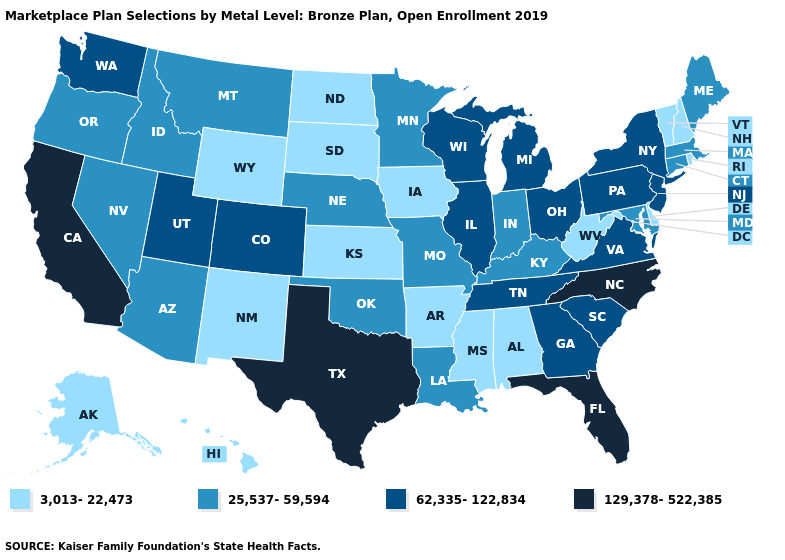What is the value of Maryland?
Write a very short answer. 25,537-59,594. What is the value of Virginia?
Concise answer only. 62,335-122,834. Name the states that have a value in the range 3,013-22,473?
Write a very short answer. Alabama, Alaska, Arkansas, Delaware, Hawaii, Iowa, Kansas, Mississippi, New Hampshire, New Mexico, North Dakota, Rhode Island, South Dakota, Vermont, West Virginia, Wyoming. Does North Carolina have a higher value than Florida?
Give a very brief answer. No. What is the lowest value in the USA?
Keep it brief. 3,013-22,473. Which states have the highest value in the USA?
Give a very brief answer. California, Florida, North Carolina, Texas. Does California have the highest value in the USA?
Answer briefly. Yes. Does Nevada have the same value as West Virginia?
Concise answer only. No. Name the states that have a value in the range 62,335-122,834?
Quick response, please. Colorado, Georgia, Illinois, Michigan, New Jersey, New York, Ohio, Pennsylvania, South Carolina, Tennessee, Utah, Virginia, Washington, Wisconsin. What is the value of Ohio?
Answer briefly. 62,335-122,834. Which states have the lowest value in the South?
Be succinct. Alabama, Arkansas, Delaware, Mississippi, West Virginia. Among the states that border Oklahoma , which have the highest value?
Short answer required. Texas. What is the lowest value in states that border Wyoming?
Answer briefly. 3,013-22,473. Name the states that have a value in the range 25,537-59,594?
Answer briefly. Arizona, Connecticut, Idaho, Indiana, Kentucky, Louisiana, Maine, Maryland, Massachusetts, Minnesota, Missouri, Montana, Nebraska, Nevada, Oklahoma, Oregon. What is the highest value in states that border New York?
Quick response, please. 62,335-122,834. 